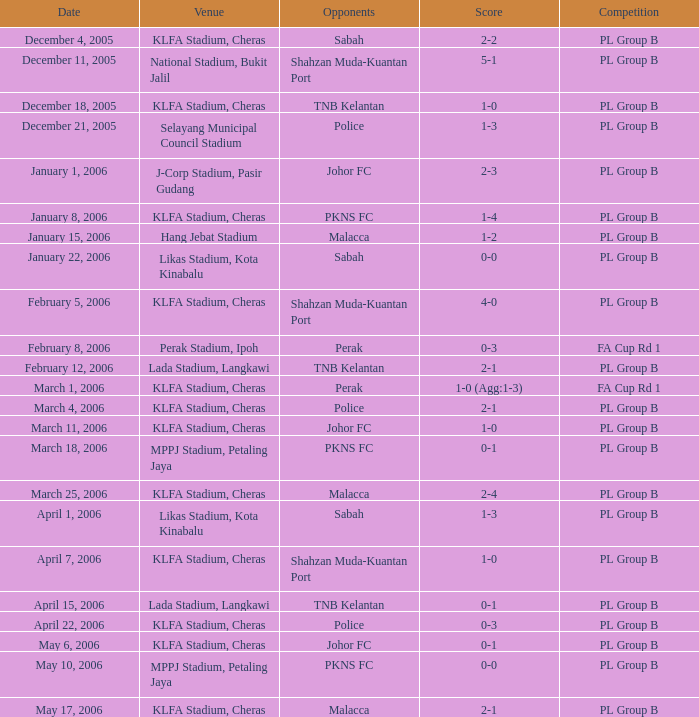Which Date has a Competition of pl group b, and Opponents of police, and a Venue of selayang municipal council stadium? December 21, 2005. 